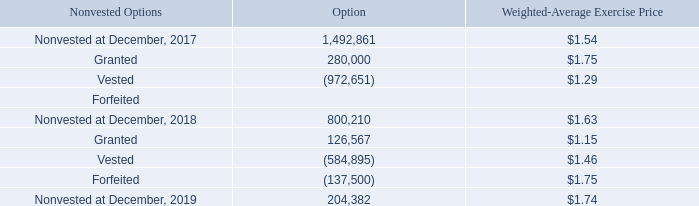A summary of the status of the Company’s nonvested options as of December 31, 2019, and changes during the year ended December 31, 2019, is presented below
As of December 31, 2019, the Company had 3,835,366 shares issuable under options outstanding at a weighted average exercise price of $1.34 and an intrinsic value of
$635,536.
As of December 31, 2019, the Company had 3,846,299 shares issuable under options outstanding at a weighted average exercise price of $1.36 and an intrinsic value of
$2,150,912.
The total number of options granted during the year ended December, 2019 and 2018 was 126,567 and 280,000, respectively. The exercise price for these options was $1.00 per share, $1.25 per share, or $1.75 per share.
The Company recognized compensation expense related to options issued of $797,761 and $1,130,071 during the year ended December 31, 2019 and 2018, respectively,
which is included in general and administrative expenses and research and development expenses. For the year ended December 31, 2019, $562,734 of the stock compensation
was related to employees and $235,027 was related to non-employees.
On January 24, 2018, the Company entered into a consulting agreement (the “Agreement”) with NeuroAssets Sàrl (“Consultant”), a Swiss company. As part of the
agreement, on February 20, 2018, the Compensation Committee of the Company’s Board of Directors approved a grant of 200,000 options under our 2016 Equity Compensation
Plan. The options vest over 48 months in equal monthly installments with the first monthly vesting event scheduled to occur on March 20, 2018, have a term of ten years and
are exercisable at a price of $1.75 per share. The vesting of the options will accelerate if a corporate partnership results from an introduction made by Consultant.
On January 24, 2018, the Company entered into a consulting agreement (the “Agreement”) with NeuroAssets Sàrl (“Consultant”), a Swiss company. As part of the agreement, on February 20, 2018, the Compensation Committee of the Company’s Board of Directors approved a grant of 200,000 options under our 2016 Equity Compensation Plan. The options vest over 48 months in equal monthly installments with the first monthly vesting event scheduled to occur on March 20, 2018, have a term of ten years and are exercisable at a price of $1.75 per share. The vesting of the options will accelerate if a corporate partnership results from an introduction made by Consultant.
During the first quarter of 2018 the Company granted 80,000 stock options to four consultants. 50,000 of these options vest immediately and the remaining 30,000
options vest monthly over 48 months, have an exercise price of $1.75, and have a term of ten years
As of December 31, 2019, the unamortized stock option expense was $287,905 with $144,423 being related to employees and $143,482 being related to non-employees.
As of December 31, 2019, the weighted average period for the unamortized stock compensation to be recognized is 3.98 years
On February 25, 2019, the Company granted 101,567 options with an exercise price of $1.00 and a ten year term. 59,900 of these options vest immediately and 41,667
vest bi-weekly over two months. These options have a Black-Scholes value of $199,807. The Company issued 59,900 options for settlement of accounts payable totaling
$29,850 and recorded a loss of $99,541 on the settlement of the accounts payable
On February 25, 2019, the Company granted 101,567 options with an exercise price of $1.00 and a ten year term. 59,900 of these options vest immediately and 41,667 vest bi-weekly over two months. These options have a Black-Scholes value of $199,807. The Company issued 59,900 options for settlement of accounts payable totaling $29,850 and recorded a loss of $99,541 on the settlement of the accounts payable.
On June 17, 2019, the Company granted 25,000 options with an exercise price of $1.75 and a ten year term. These options vest immediately and have a Black-Scholes
value of $36,374
What is the number of nonvested options at December 31, 2017? 1,492,861. What is the number of nonvested options at December 31, 2018? 800,210. What is the number of nonvested options at December 31, 2019? 204,382. What is the percentage of nonvested options at December 31, 2019 as a percentage of the total shares issued?
Answer scale should be: percent. 204,382/3,835,366 
Answer: 5.33. What is the difference in the weighted average exercise price of the outstanding and nonvested options as at December 31, 2019? 1.74 - 1.34 
Answer: 0.4. What is the percentage of options granted during the year ended December 2018 as a percentage of the number of nonvested options remaining as at 31 December 2018?
Answer scale should be: percent. 280,000/800,210 
Answer: 34.99. 